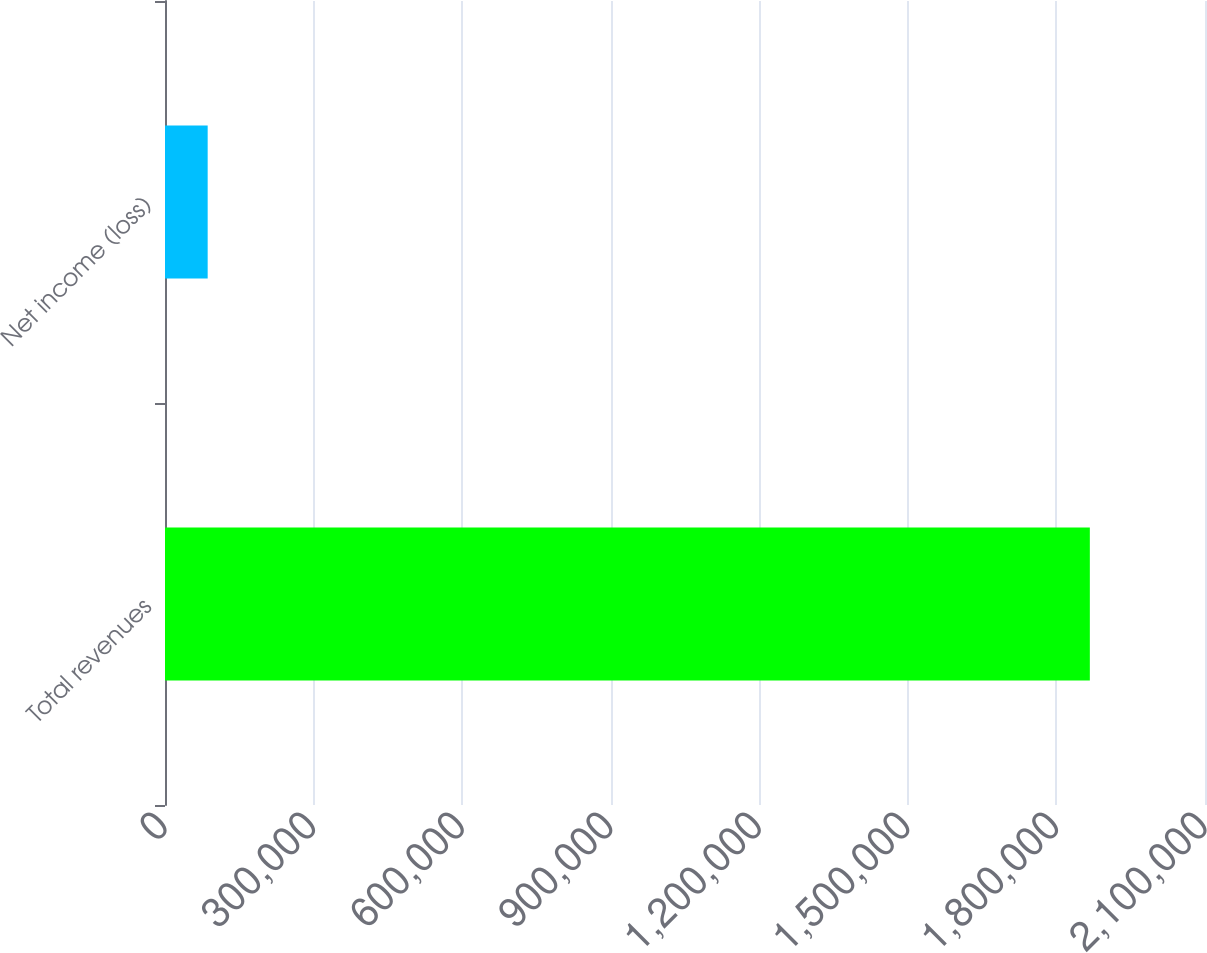<chart> <loc_0><loc_0><loc_500><loc_500><bar_chart><fcel>Total revenues<fcel>Net income (loss)<nl><fcel>1.86746e+06<fcel>86167<nl></chart> 